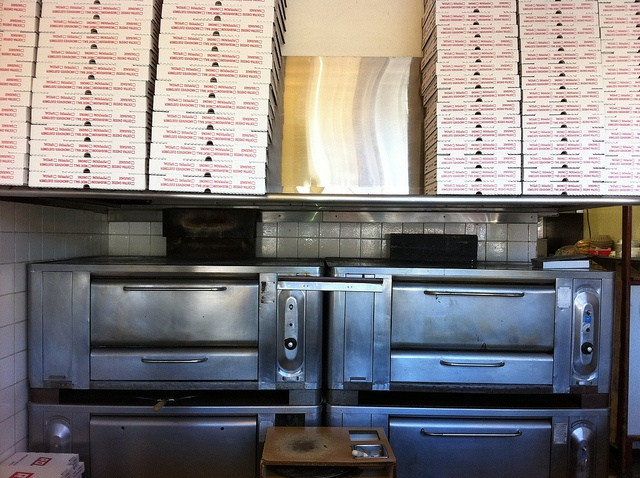Describe the objects in this image and their specific colors. I can see oven in tan, black, and gray tones and oven in tan, black, navy, and gray tones in this image. 